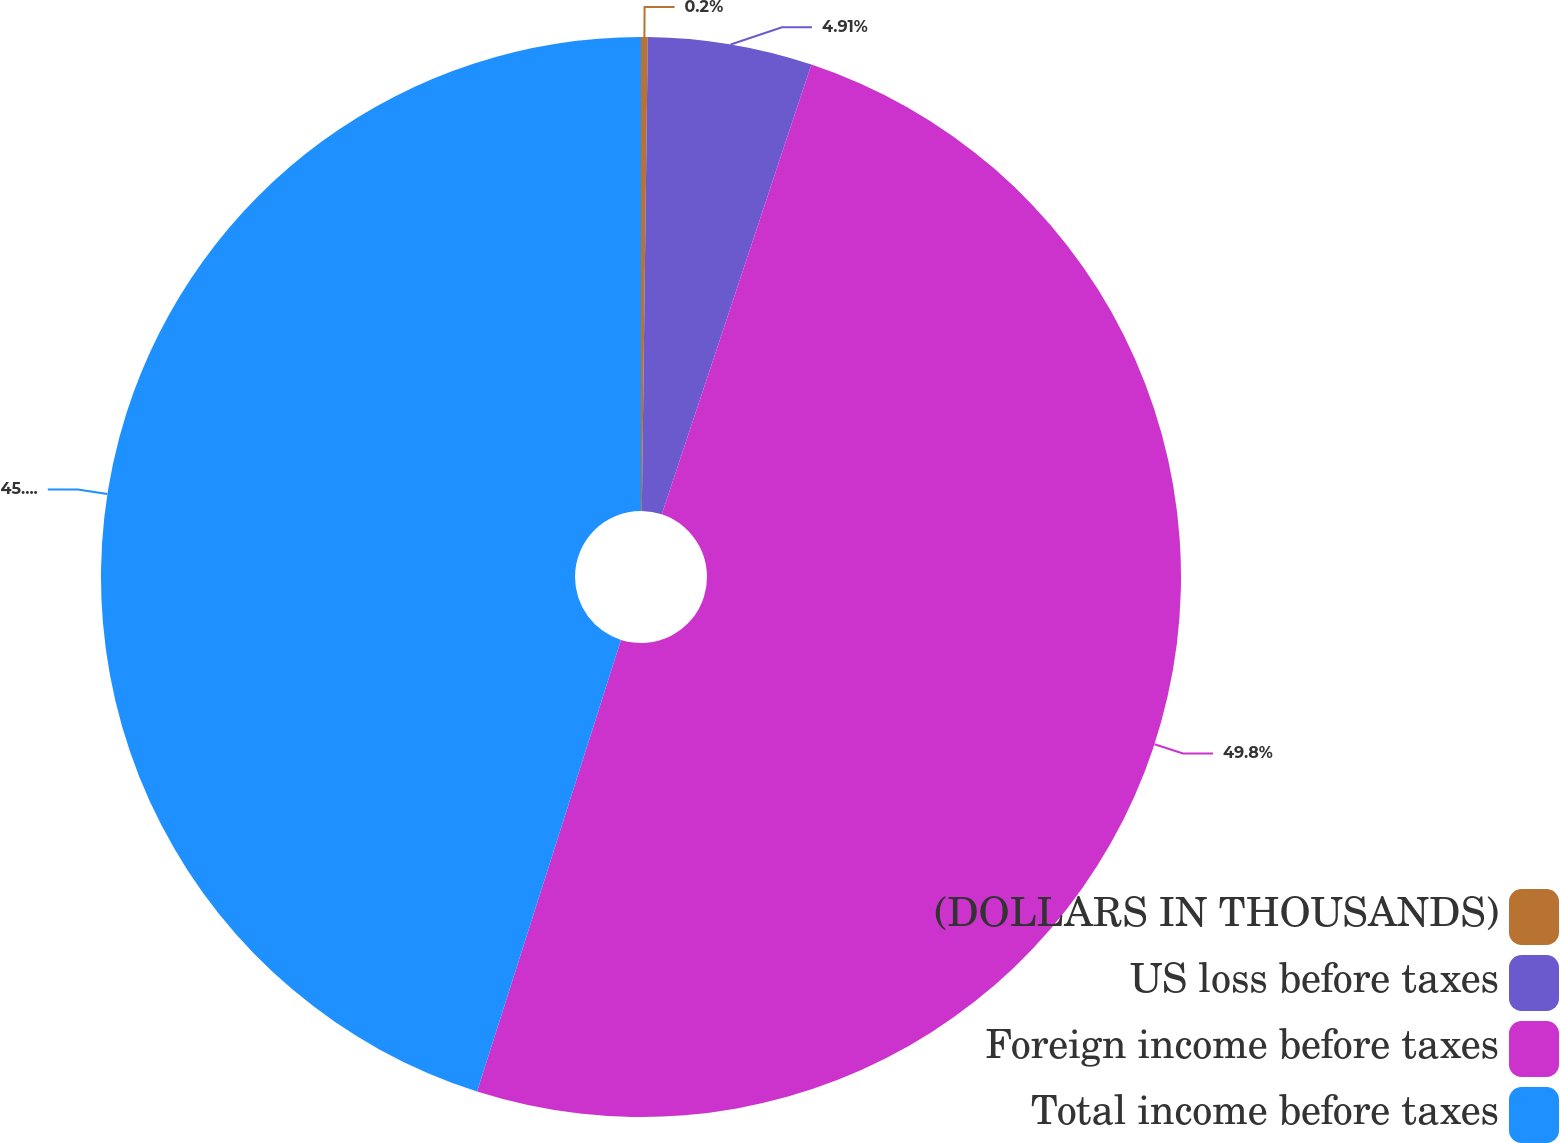<chart> <loc_0><loc_0><loc_500><loc_500><pie_chart><fcel>(DOLLARS IN THOUSANDS)<fcel>US loss before taxes<fcel>Foreign income before taxes<fcel>Total income before taxes<nl><fcel>0.2%<fcel>4.91%<fcel>49.8%<fcel>45.09%<nl></chart> 